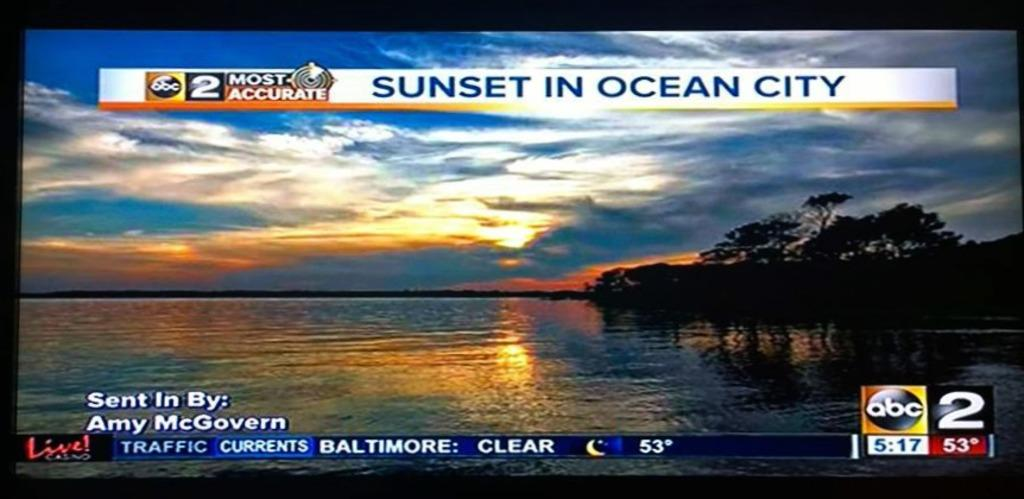<image>
Render a clear and concise summary of the photo. The news shows the sunset in Ocean City. 